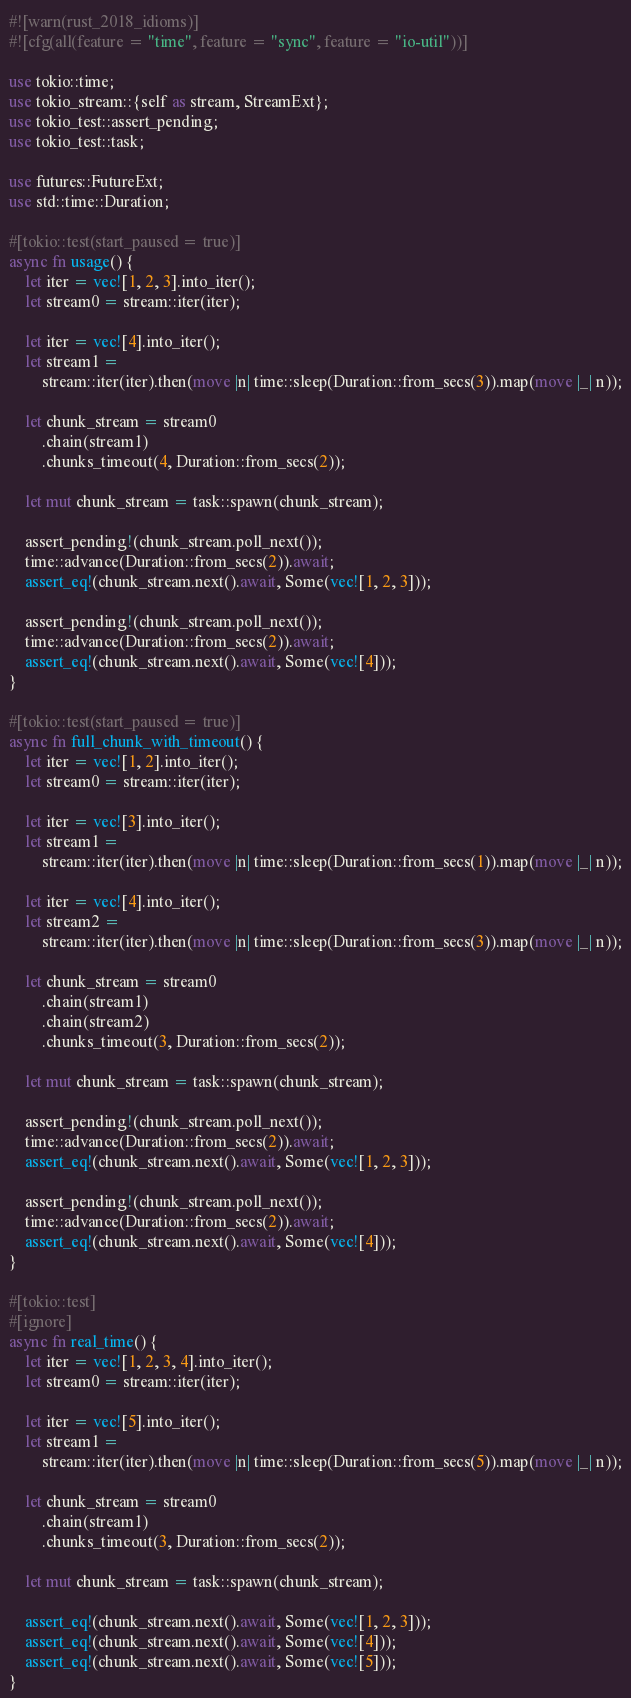Convert code to text. <code><loc_0><loc_0><loc_500><loc_500><_Rust_>#![warn(rust_2018_idioms)]
#![cfg(all(feature = "time", feature = "sync", feature = "io-util"))]

use tokio::time;
use tokio_stream::{self as stream, StreamExt};
use tokio_test::assert_pending;
use tokio_test::task;

use futures::FutureExt;
use std::time::Duration;

#[tokio::test(start_paused = true)]
async fn usage() {
    let iter = vec![1, 2, 3].into_iter();
    let stream0 = stream::iter(iter);

    let iter = vec![4].into_iter();
    let stream1 =
        stream::iter(iter).then(move |n| time::sleep(Duration::from_secs(3)).map(move |_| n));

    let chunk_stream = stream0
        .chain(stream1)
        .chunks_timeout(4, Duration::from_secs(2));

    let mut chunk_stream = task::spawn(chunk_stream);

    assert_pending!(chunk_stream.poll_next());
    time::advance(Duration::from_secs(2)).await;
    assert_eq!(chunk_stream.next().await, Some(vec![1, 2, 3]));

    assert_pending!(chunk_stream.poll_next());
    time::advance(Duration::from_secs(2)).await;
    assert_eq!(chunk_stream.next().await, Some(vec![4]));
}

#[tokio::test(start_paused = true)]
async fn full_chunk_with_timeout() {
    let iter = vec![1, 2].into_iter();
    let stream0 = stream::iter(iter);

    let iter = vec![3].into_iter();
    let stream1 =
        stream::iter(iter).then(move |n| time::sleep(Duration::from_secs(1)).map(move |_| n));

    let iter = vec![4].into_iter();
    let stream2 =
        stream::iter(iter).then(move |n| time::sleep(Duration::from_secs(3)).map(move |_| n));

    let chunk_stream = stream0
        .chain(stream1)
        .chain(stream2)
        .chunks_timeout(3, Duration::from_secs(2));

    let mut chunk_stream = task::spawn(chunk_stream);

    assert_pending!(chunk_stream.poll_next());
    time::advance(Duration::from_secs(2)).await;
    assert_eq!(chunk_stream.next().await, Some(vec![1, 2, 3]));

    assert_pending!(chunk_stream.poll_next());
    time::advance(Duration::from_secs(2)).await;
    assert_eq!(chunk_stream.next().await, Some(vec![4]));
}

#[tokio::test]
#[ignore]
async fn real_time() {
    let iter = vec![1, 2, 3, 4].into_iter();
    let stream0 = stream::iter(iter);

    let iter = vec![5].into_iter();
    let stream1 =
        stream::iter(iter).then(move |n| time::sleep(Duration::from_secs(5)).map(move |_| n));

    let chunk_stream = stream0
        .chain(stream1)
        .chunks_timeout(3, Duration::from_secs(2));

    let mut chunk_stream = task::spawn(chunk_stream);

    assert_eq!(chunk_stream.next().await, Some(vec![1, 2, 3]));
    assert_eq!(chunk_stream.next().await, Some(vec![4]));
    assert_eq!(chunk_stream.next().await, Some(vec![5]));
}
</code> 